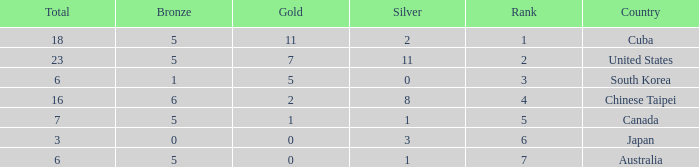What is the lowest total medals for the united states who had more than 11 silver medals? None. 